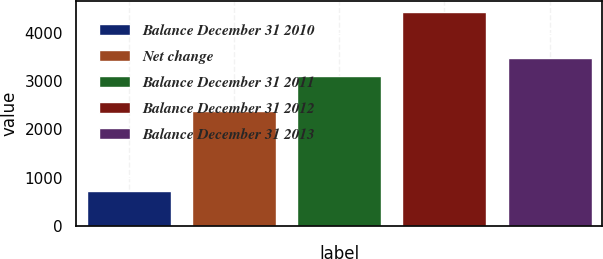Convert chart to OTSL. <chart><loc_0><loc_0><loc_500><loc_500><bar_chart><fcel>Balance December 31 2010<fcel>Net change<fcel>Balance December 31 2011<fcel>Balance December 31 2012<fcel>Balance December 31 2013<nl><fcel>714<fcel>2386<fcel>3100<fcel>4443<fcel>3472.9<nl></chart> 